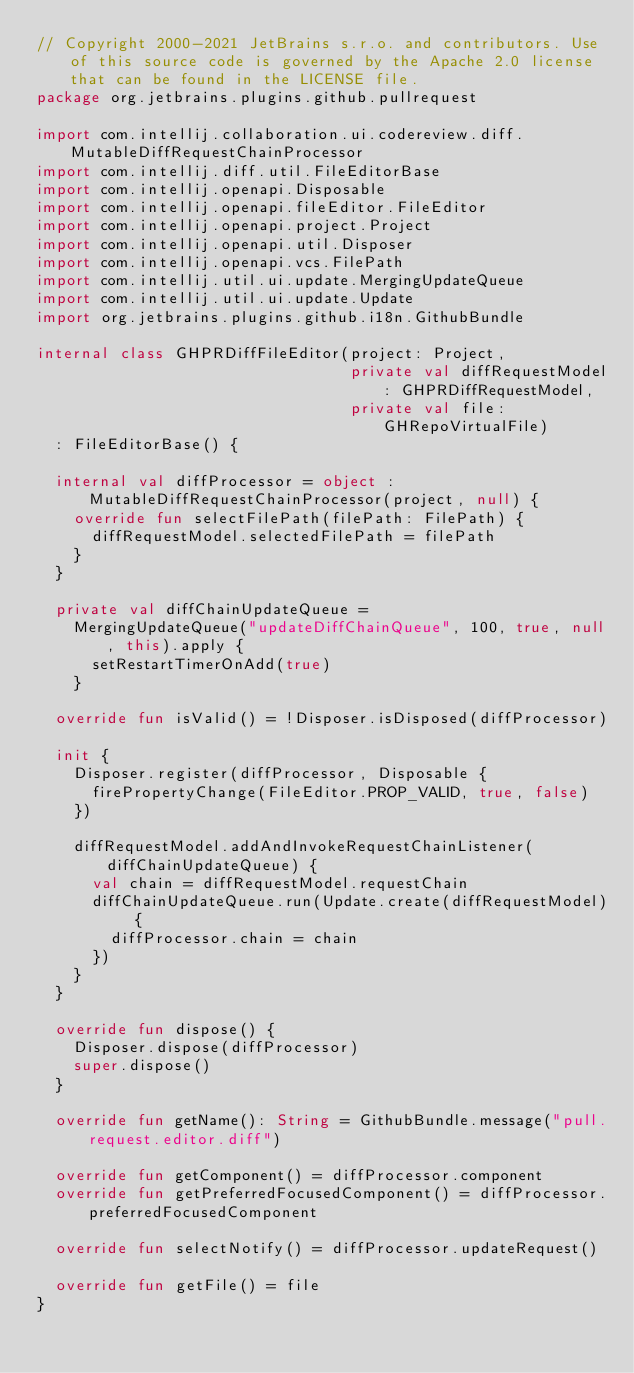Convert code to text. <code><loc_0><loc_0><loc_500><loc_500><_Kotlin_>// Copyright 2000-2021 JetBrains s.r.o. and contributors. Use of this source code is governed by the Apache 2.0 license that can be found in the LICENSE file.
package org.jetbrains.plugins.github.pullrequest

import com.intellij.collaboration.ui.codereview.diff.MutableDiffRequestChainProcessor
import com.intellij.diff.util.FileEditorBase
import com.intellij.openapi.Disposable
import com.intellij.openapi.fileEditor.FileEditor
import com.intellij.openapi.project.Project
import com.intellij.openapi.util.Disposer
import com.intellij.openapi.vcs.FilePath
import com.intellij.util.ui.update.MergingUpdateQueue
import com.intellij.util.ui.update.Update
import org.jetbrains.plugins.github.i18n.GithubBundle

internal class GHPRDiffFileEditor(project: Project,
                                  private val diffRequestModel: GHPRDiffRequestModel,
                                  private val file: GHRepoVirtualFile)
  : FileEditorBase() {

  internal val diffProcessor = object : MutableDiffRequestChainProcessor(project, null) {
    override fun selectFilePath(filePath: FilePath) {
      diffRequestModel.selectedFilePath = filePath
    }
  }

  private val diffChainUpdateQueue =
    MergingUpdateQueue("updateDiffChainQueue", 100, true, null, this).apply {
      setRestartTimerOnAdd(true)
    }

  override fun isValid() = !Disposer.isDisposed(diffProcessor)

  init {
    Disposer.register(diffProcessor, Disposable {
      firePropertyChange(FileEditor.PROP_VALID, true, false)
    })

    diffRequestModel.addAndInvokeRequestChainListener(diffChainUpdateQueue) {
      val chain = diffRequestModel.requestChain
      diffChainUpdateQueue.run(Update.create(diffRequestModel) {
        diffProcessor.chain = chain
      })
    }
  }

  override fun dispose() {
    Disposer.dispose(diffProcessor)
    super.dispose()
  }

  override fun getName(): String = GithubBundle.message("pull.request.editor.diff")

  override fun getComponent() = diffProcessor.component
  override fun getPreferredFocusedComponent() = diffProcessor.preferredFocusedComponent

  override fun selectNotify() = diffProcessor.updateRequest()

  override fun getFile() = file
}
</code> 